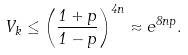<formula> <loc_0><loc_0><loc_500><loc_500>V _ { k } \leq \left ( \frac { 1 + p } { 1 - p } \right ) ^ { 4 n } \approx e ^ { 8 n p } .</formula> 